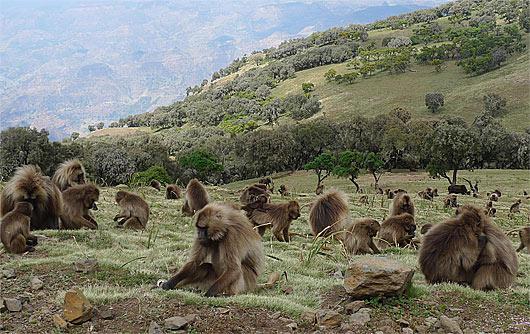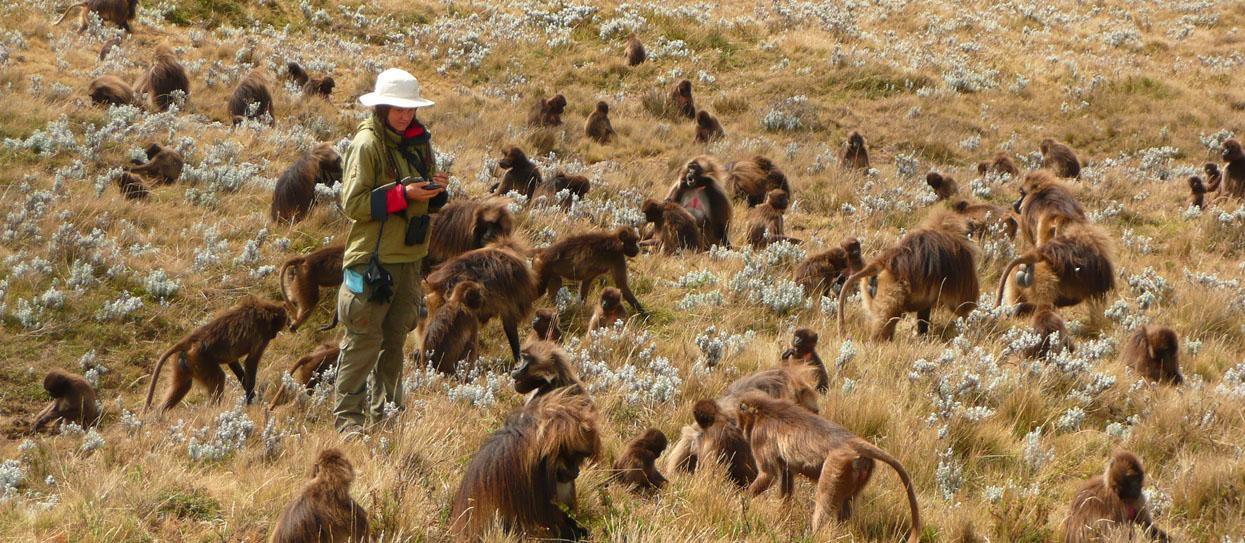The first image is the image on the left, the second image is the image on the right. For the images shown, is this caption "A red fox-like animal is standing in a scene near some monkeys." true? Answer yes or no. No. The first image is the image on the left, the second image is the image on the right. For the images displayed, is the sentence "A single wild dog sits in the wild with the primates." factually correct? Answer yes or no. No. 